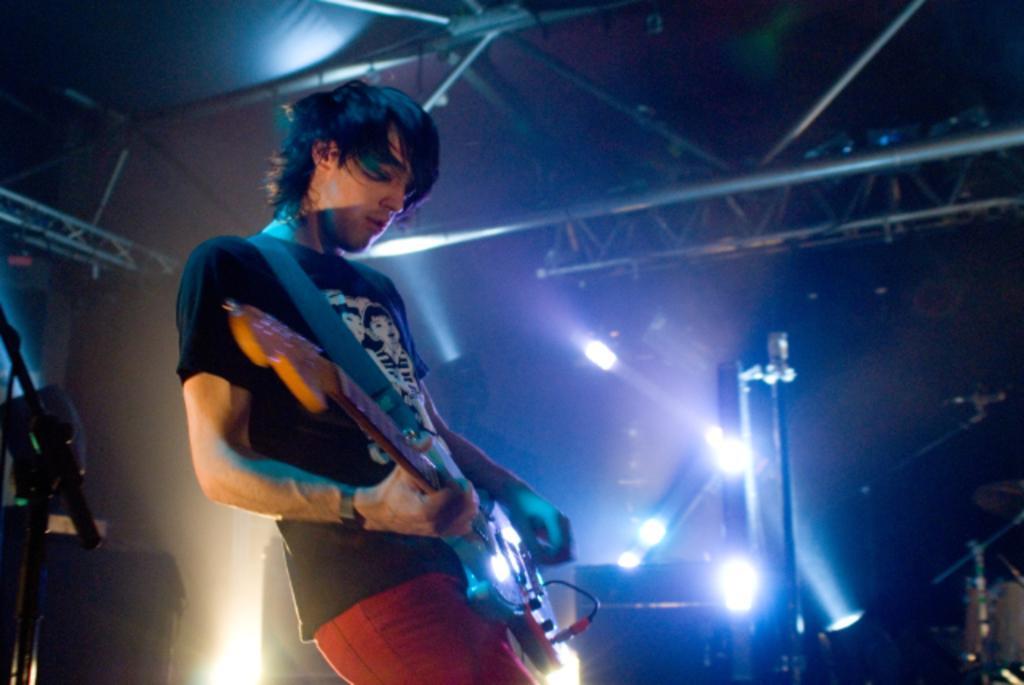Describe this image in one or two sentences. This man is playing guitar. On top there are focusing lights. 